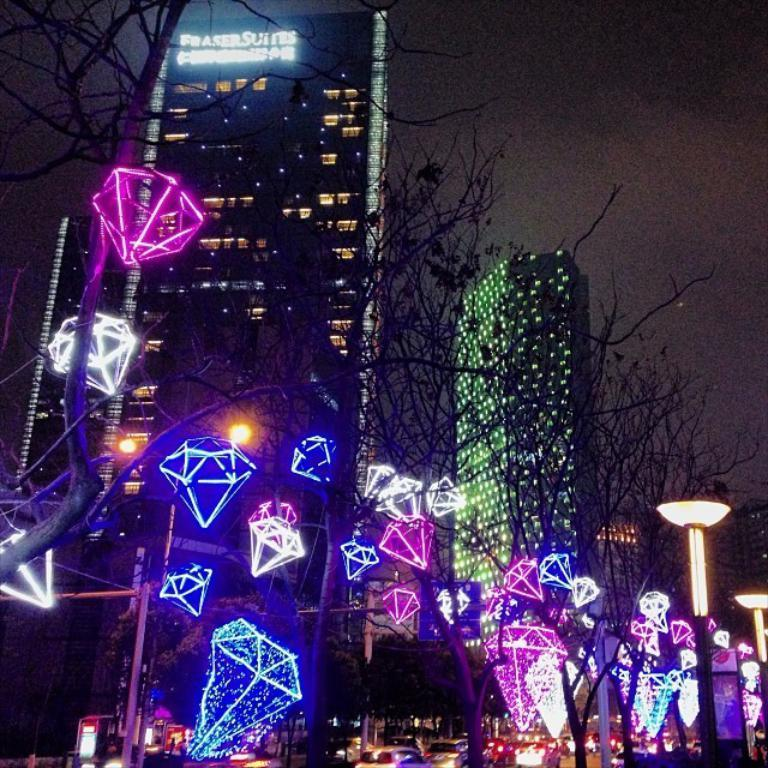What type of natural elements can be seen in the image? There are trees in the image. What is attached to the trees? Lights are attached to the trees. What can be seen in the background of the image? There are vehicles on the road and buildings visible in the background. Where is the kettle placed in the image? There is no kettle present in the image. 